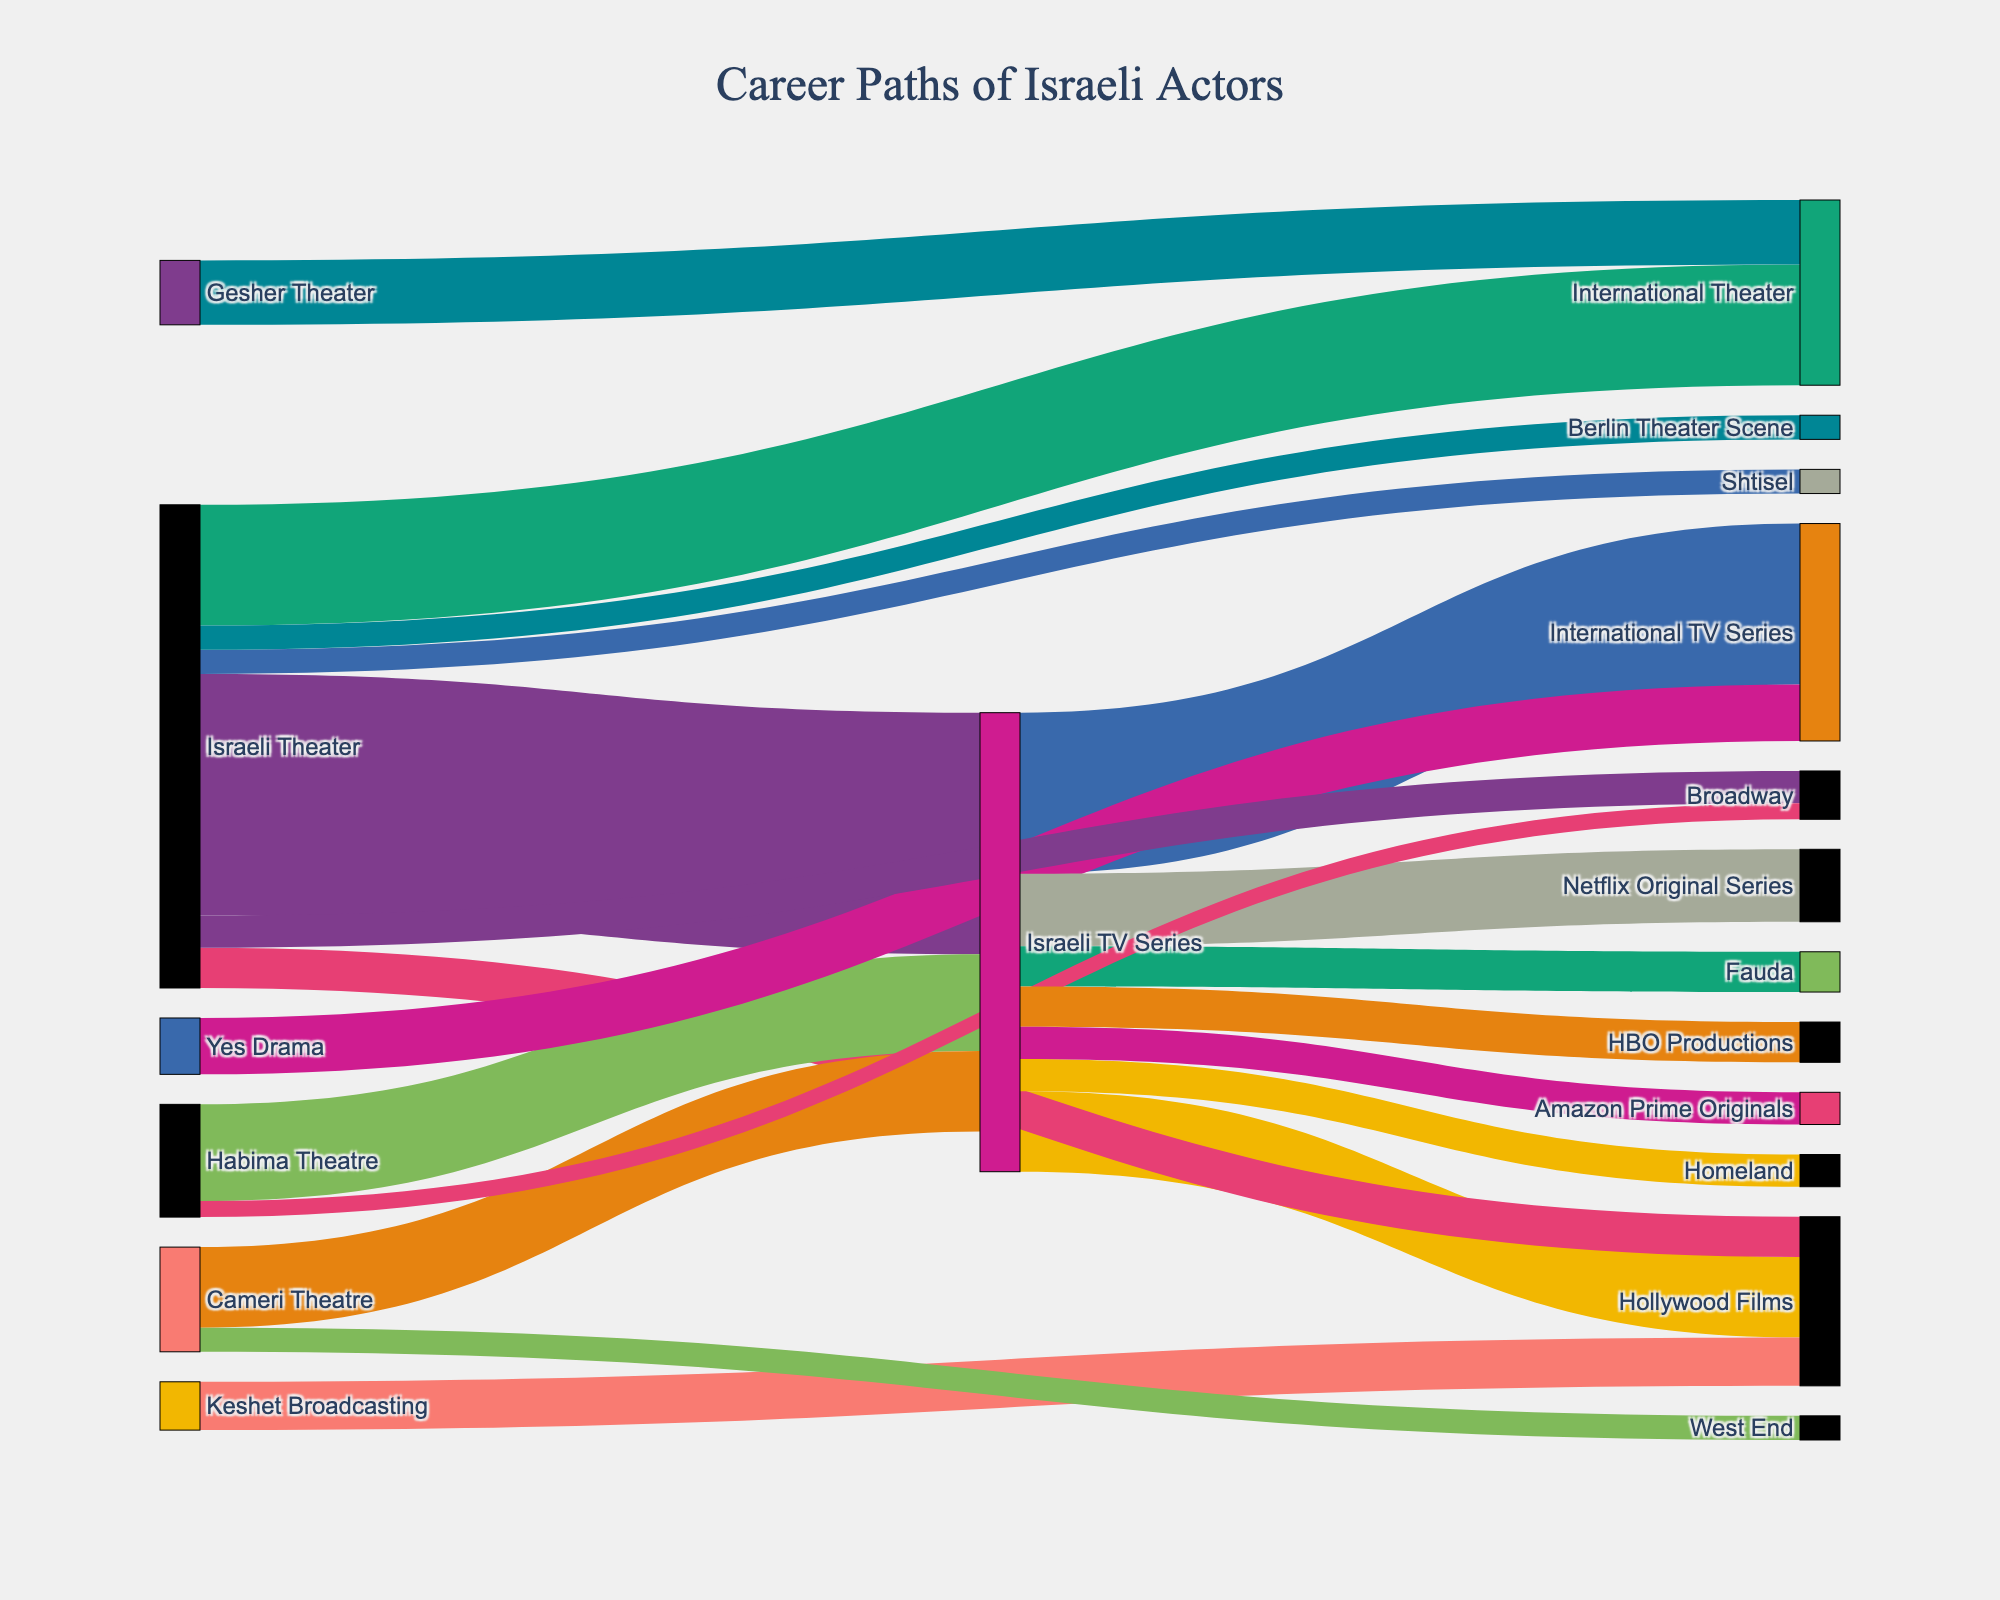What is the title of the Sankey Diagram? The title is usually positioned at the top of the figure and helps to provide context for what the diagram represents. In this case, it is given in the layout update command in the code.
Answer: "Career Paths of Israeli Actors" How many actors transitioned from the Habima Theatre to Broadway? By looking at the connecting link between "Habima Theatre" and "Broadway" and checking the value associated with that link, we can find the answer.
Answer: 2 Which transition has the highest number of actors? To determine this, we need to compare the values of all the links in the diagram and find the highest one.
Answer: Israeli Theater to Israeli TV Series What is the combined number of actors who moved from Israeli Theater to International Theater and from Israeli Theater to Hollywood Films? We need to sum the values associated with the transitions from "Israeli Theater" to "International Theater" and from "Israeli Theater" to "Hollywood Films".
Answer: 20 (15 + 5) How many actors from the Cameri Theatre transitioned to other platforms? We need to sum the values of all the links originating from "Cameri Theatre" which includes transitions to "Israeli TV Series" and "West End".
Answer: 13 (10 + 3) Which source has the most number of different transition targets? To find this, count the unique targets for each source and determine which has the most.
Answer: Israeli TV Series Compare the transitions from Israeli TV Series to Netflix Original Series and Amazon Prime Originals, which has more actors? We need to compare the values of the transitions from "Israeli TV Series" to "Netflix Original Series" and "Amazon Prime Originals".
Answer: Netflix Original Series What is the total number of actors that transitioned to International TV Series? Summing up the values of all transitions whose target is "International TV Series" will give us the answer.
Answer: 27 (20 + 7) From which theater did the smallest number of actors transition to international productions? Check the values of transitions from each theater to any international productions (International Theater, Broadway, West End, Hollywood Films, Berlin Theater Scene) and find the smallest.
Answer: Habima Theatre 